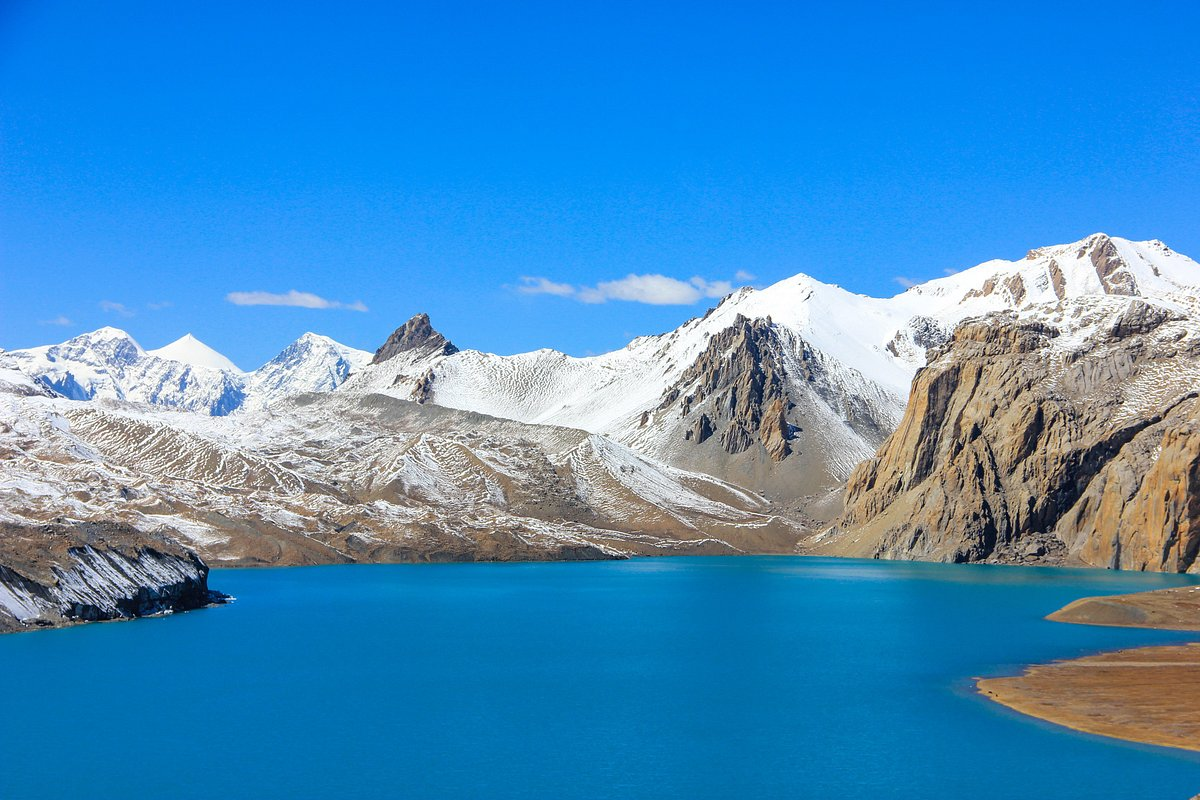What do you see happening in this image?
 The image captures the breathtaking view of Tilicho Lake, nestled in the Annapurna range of the Himalayas. The lake, known for its bright blue color, is the main focus of the image. It's a glacial lake, and its vibrant hue contrasts beautifully with the surrounding landscape.

The lake is encircled by majestic snow-capped mountains, their white peaks standing in stark contrast to the clear blue sky above. The perspective of the image is from a high vantage point, providing a panoramic view of the lake and the mountains. This perspective allows for a comprehensive view of the lake's vastness and the towering mountains that surround it.

The image does an excellent job of capturing the serene and untouched beauty of this remote location. The clear blue sky, the bright blue lake, and the snow-capped mountains combine to create a truly stunning visual spectacle. The image is a testament to the natural beauty of Tilicho Lake and the Annapurna range. 